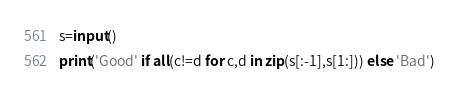<code> <loc_0><loc_0><loc_500><loc_500><_Python_>s=input()
print('Good' if all(c!=d for c,d in zip(s[:-1],s[1:])) else 'Bad')

</code> 